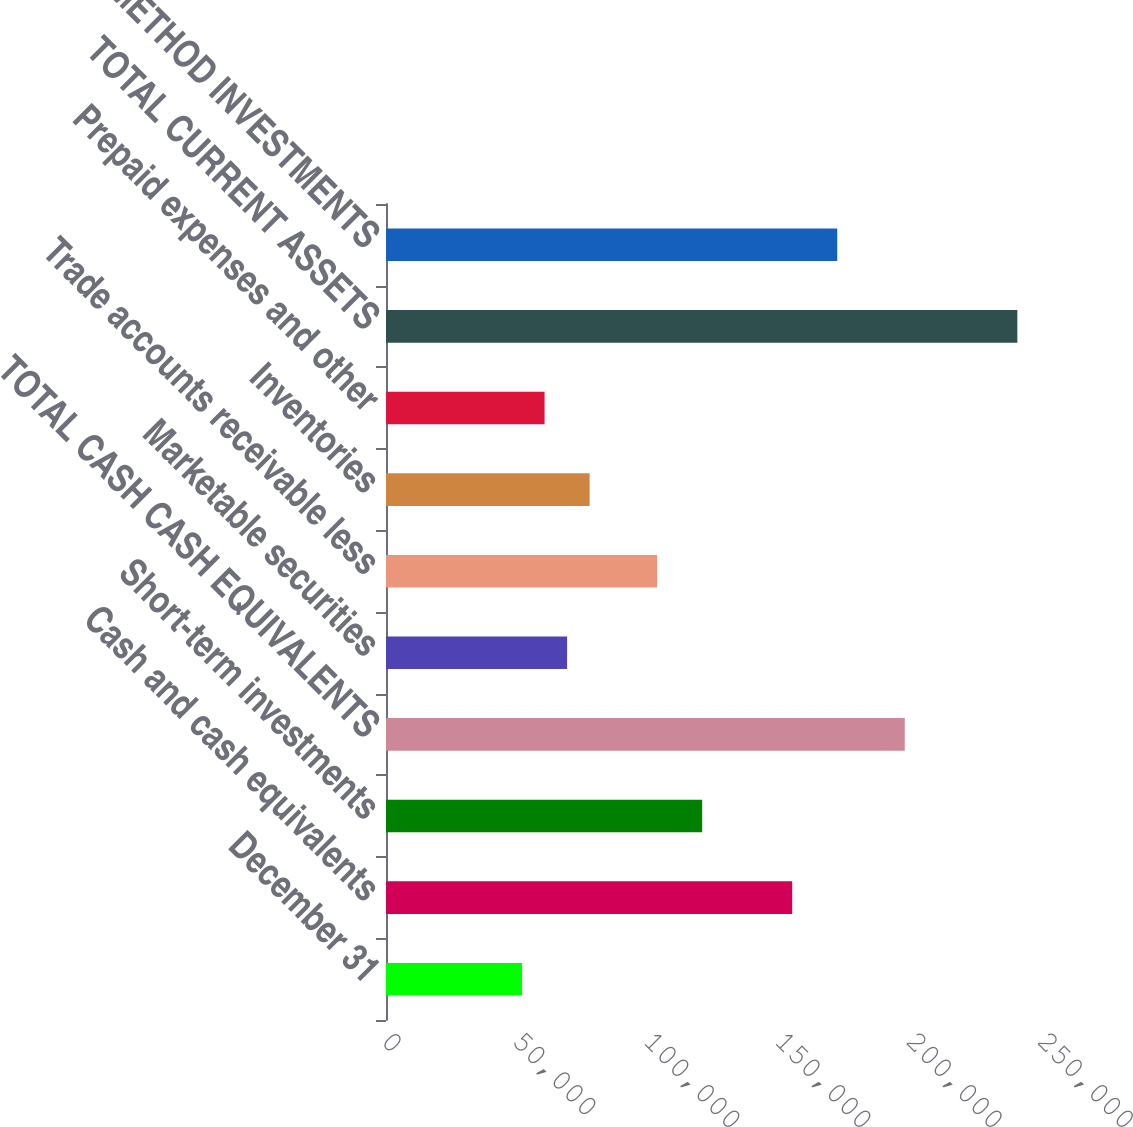Convert chart. <chart><loc_0><loc_0><loc_500><loc_500><bar_chart><fcel>December 31<fcel>Cash and cash equivalents<fcel>Short-term investments<fcel>TOTAL CASH CASH EQUIVALENTS<fcel>Marketable securities<fcel>Trade accounts receivable less<fcel>Inventories<fcel>Prepaid expenses and other<fcel>TOTAL CURRENT ASSETS<fcel>EQUITY METHOD INVESTMENTS<nl><fcel>51855.6<fcel>154811<fcel>120492<fcel>197709<fcel>69014.8<fcel>103333<fcel>77594.4<fcel>60435.2<fcel>240607<fcel>171970<nl></chart> 